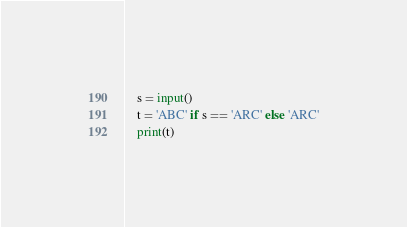Convert code to text. <code><loc_0><loc_0><loc_500><loc_500><_Python_>    s = input()
    t = 'ABC' if s == 'ARC' else 'ARC'
    print(t)</code> 